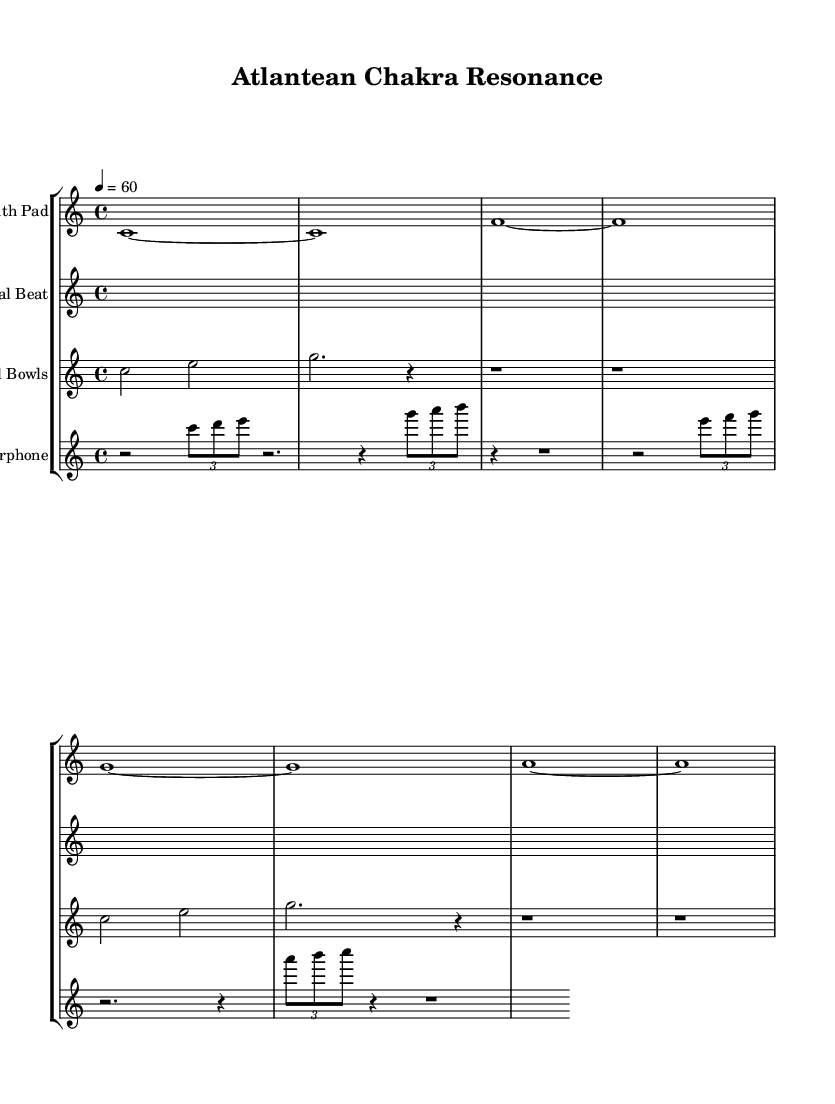What is the key signature of this music? The key signature is C major, which has no sharps or flats.
Answer: C major What is the time signature used in this piece? The time signature is indicated at the beginning as 4/4, meaning there are four beats in each measure, and the quarter note gets the beat.
Answer: 4/4 What is the tempo marking for this composition? The tempo is indicated as 4 = 60, meaning there are 60 quarter note beats per minute.
Answer: 60 How many different instrumental staffs are present in the score? There are four different instrumental staffs in the score: Synth Pad, Binaural Beat, Crystal Bowls, and Waterphone, totaling four distinct instruments.
Answer: 4 What type of instrument is used for the first staff? The first staff is labeled "Synth Pad," which indicates it utilizes synthetic sounds often used in ambient electronic music.
Answer: Synth Pad Which staff features the waterphone? The last staff is labeled "Waterphone," suggesting that it incorporates this unique instrument, known for its ethereal and resonant qualities.
Answer: Waterphone What rhythmic pattern is mainly used for the Binaural Beat staff? The Binaural Beat staff primarily features rests (silent beats) with no pitches, creating a rhythmic silence designed to influence brainwave states in binaural beat therapy.
Answer: Silence 